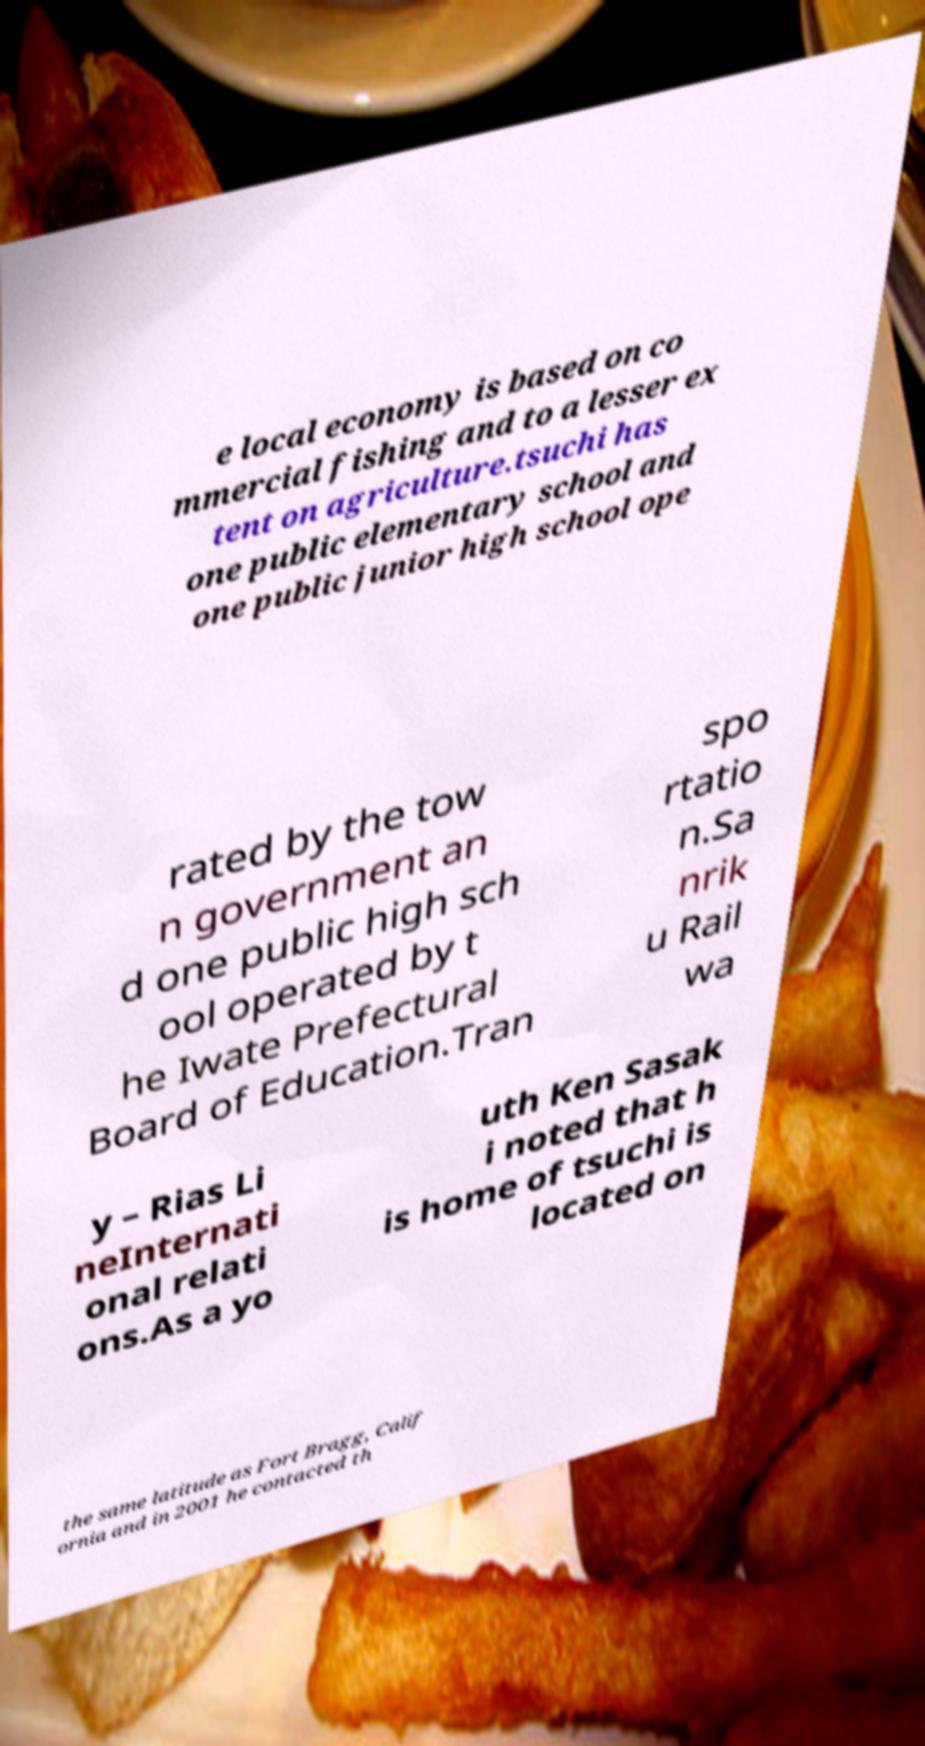I need the written content from this picture converted into text. Can you do that? e local economy is based on co mmercial fishing and to a lesser ex tent on agriculture.tsuchi has one public elementary school and one public junior high school ope rated by the tow n government an d one public high sch ool operated by t he Iwate Prefectural Board of Education.Tran spo rtatio n.Sa nrik u Rail wa y – Rias Li neInternati onal relati ons.As a yo uth Ken Sasak i noted that h is home of tsuchi is located on the same latitude as Fort Bragg, Calif ornia and in 2001 he contacted th 